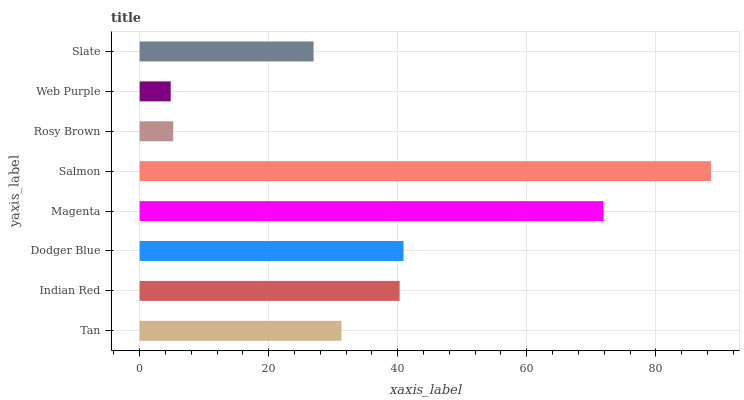Is Web Purple the minimum?
Answer yes or no. Yes. Is Salmon the maximum?
Answer yes or no. Yes. Is Indian Red the minimum?
Answer yes or no. No. Is Indian Red the maximum?
Answer yes or no. No. Is Indian Red greater than Tan?
Answer yes or no. Yes. Is Tan less than Indian Red?
Answer yes or no. Yes. Is Tan greater than Indian Red?
Answer yes or no. No. Is Indian Red less than Tan?
Answer yes or no. No. Is Indian Red the high median?
Answer yes or no. Yes. Is Tan the low median?
Answer yes or no. Yes. Is Rosy Brown the high median?
Answer yes or no. No. Is Rosy Brown the low median?
Answer yes or no. No. 